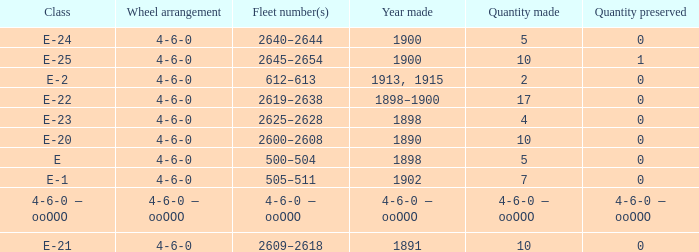What is the fleet number with a 4-6-0 wheel arrangement made in 1890? 2600–2608. 